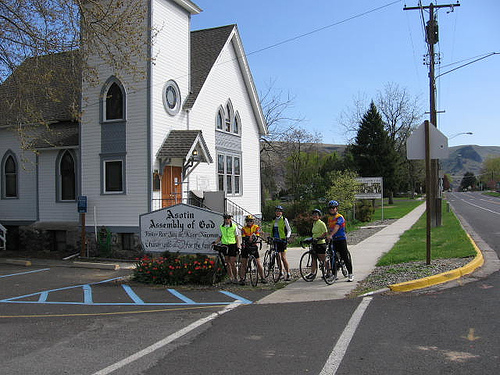Read and extract the text from this image. Asatin Assembly of God 